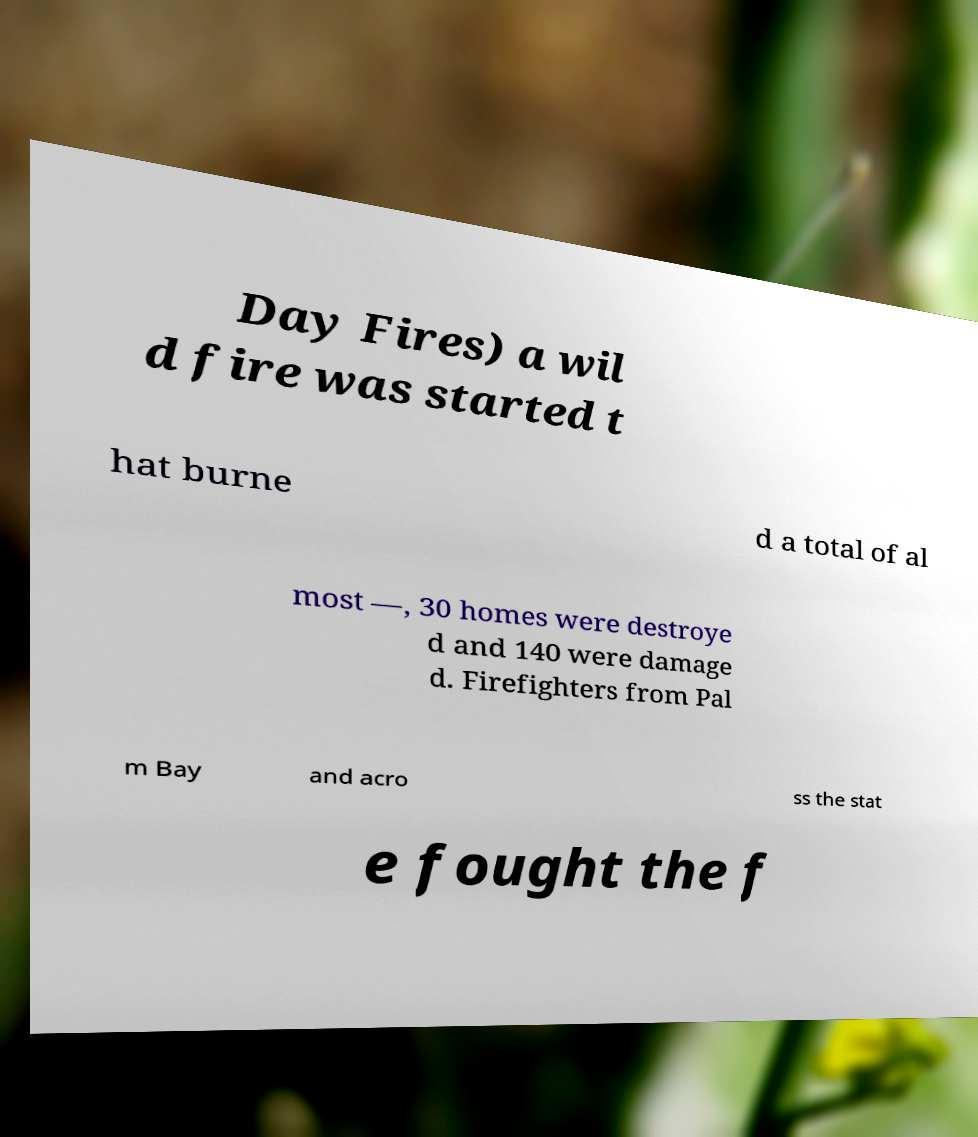What messages or text are displayed in this image? I need them in a readable, typed format. Day Fires) a wil d fire was started t hat burne d a total of al most —, 30 homes were destroye d and 140 were damage d. Firefighters from Pal m Bay and acro ss the stat e fought the f 